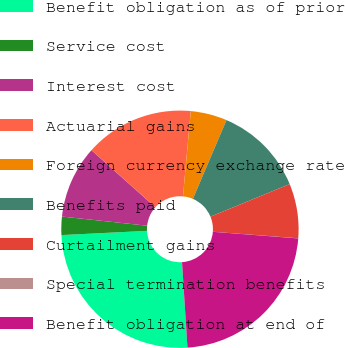Convert chart. <chart><loc_0><loc_0><loc_500><loc_500><pie_chart><fcel>Benefit obligation as of prior<fcel>Service cost<fcel>Interest cost<fcel>Actuarial gains<fcel>Foreign currency exchange rate<fcel>Benefits paid<fcel>Curtailment gains<fcel>Special termination benefits<fcel>Benefit obligation at end of<nl><fcel>25.22%<fcel>2.49%<fcel>9.9%<fcel>14.85%<fcel>4.96%<fcel>12.37%<fcel>7.43%<fcel>0.02%<fcel>22.75%<nl></chart> 